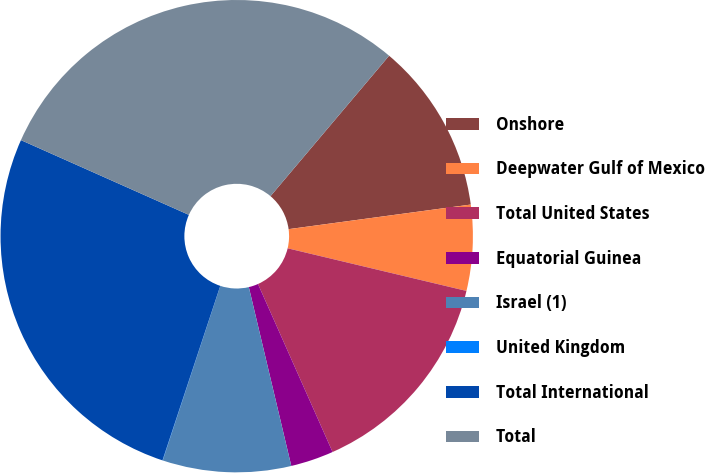Convert chart. <chart><loc_0><loc_0><loc_500><loc_500><pie_chart><fcel>Onshore<fcel>Deepwater Gulf of Mexico<fcel>Total United States<fcel>Equatorial Guinea<fcel>Israel (1)<fcel>United Kingdom<fcel>Total International<fcel>Total<nl><fcel>11.7%<fcel>5.86%<fcel>14.62%<fcel>2.94%<fcel>8.78%<fcel>0.02%<fcel>26.57%<fcel>29.49%<nl></chart> 